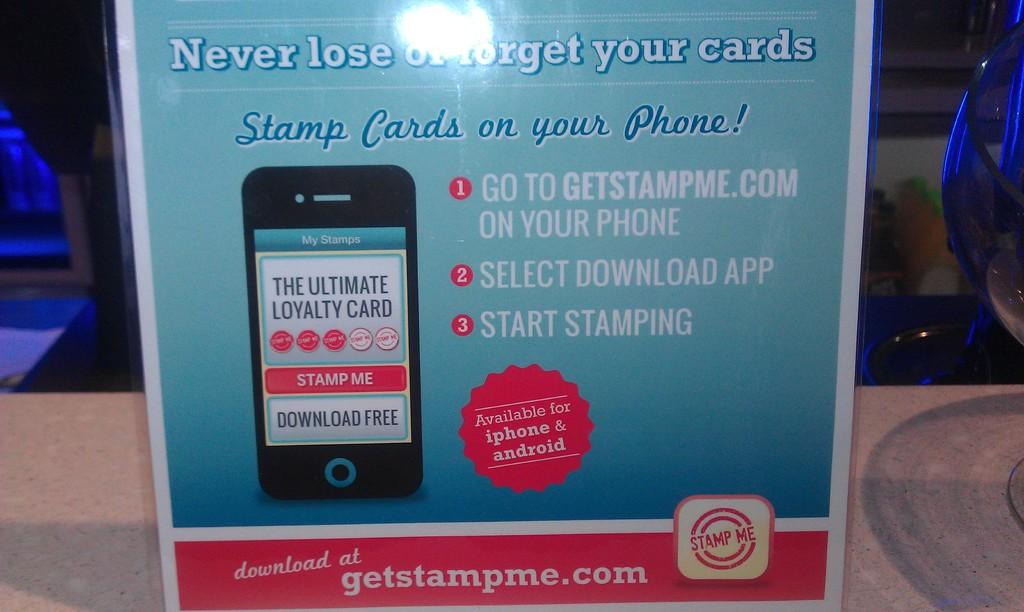<image>
Describe the image concisely. A flyer for an app for your phone called get stamp me. 